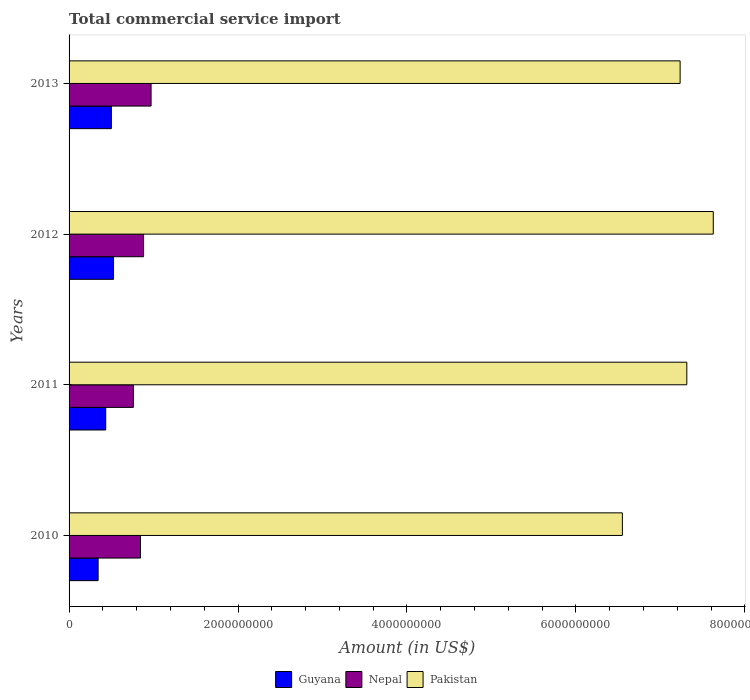How many groups of bars are there?
Offer a very short reply. 4. What is the label of the 4th group of bars from the top?
Your response must be concise. 2010. In how many cases, is the number of bars for a given year not equal to the number of legend labels?
Your answer should be compact. 0. What is the total commercial service import in Nepal in 2011?
Keep it short and to the point. 7.61e+08. Across all years, what is the maximum total commercial service import in Pakistan?
Your answer should be compact. 7.63e+09. Across all years, what is the minimum total commercial service import in Pakistan?
Your response must be concise. 6.55e+09. What is the total total commercial service import in Nepal in the graph?
Offer a terse response. 3.46e+09. What is the difference between the total commercial service import in Guyana in 2012 and that in 2013?
Ensure brevity in your answer.  2.60e+07. What is the difference between the total commercial service import in Nepal in 2010 and the total commercial service import in Guyana in 2011?
Provide a short and direct response. 4.11e+08. What is the average total commercial service import in Nepal per year?
Your answer should be compact. 8.65e+08. In the year 2010, what is the difference between the total commercial service import in Guyana and total commercial service import in Pakistan?
Give a very brief answer. -6.21e+09. What is the ratio of the total commercial service import in Nepal in 2011 to that in 2012?
Offer a terse response. 0.86. Is the total commercial service import in Guyana in 2012 less than that in 2013?
Offer a terse response. No. What is the difference between the highest and the second highest total commercial service import in Guyana?
Make the answer very short. 2.60e+07. What is the difference between the highest and the lowest total commercial service import in Nepal?
Give a very brief answer. 2.09e+08. Is the sum of the total commercial service import in Guyana in 2010 and 2013 greater than the maximum total commercial service import in Nepal across all years?
Ensure brevity in your answer.  No. What does the 3rd bar from the top in 2013 represents?
Provide a succinct answer. Guyana. What does the 1st bar from the bottom in 2010 represents?
Your response must be concise. Guyana. Is it the case that in every year, the sum of the total commercial service import in Guyana and total commercial service import in Nepal is greater than the total commercial service import in Pakistan?
Your answer should be very brief. No. Are all the bars in the graph horizontal?
Ensure brevity in your answer.  Yes. How many years are there in the graph?
Give a very brief answer. 4. How are the legend labels stacked?
Provide a short and direct response. Horizontal. What is the title of the graph?
Provide a succinct answer. Total commercial service import. What is the label or title of the X-axis?
Ensure brevity in your answer.  Amount (in US$). What is the label or title of the Y-axis?
Provide a short and direct response. Years. What is the Amount (in US$) in Guyana in 2010?
Your answer should be compact. 3.44e+08. What is the Amount (in US$) in Nepal in 2010?
Your answer should be very brief. 8.45e+08. What is the Amount (in US$) in Pakistan in 2010?
Your response must be concise. 6.55e+09. What is the Amount (in US$) in Guyana in 2011?
Provide a succinct answer. 4.34e+08. What is the Amount (in US$) of Nepal in 2011?
Provide a succinct answer. 7.61e+08. What is the Amount (in US$) in Pakistan in 2011?
Provide a short and direct response. 7.31e+09. What is the Amount (in US$) of Guyana in 2012?
Offer a terse response. 5.26e+08. What is the Amount (in US$) in Nepal in 2012?
Your answer should be very brief. 8.82e+08. What is the Amount (in US$) of Pakistan in 2012?
Your answer should be compact. 7.63e+09. What is the Amount (in US$) of Guyana in 2013?
Your response must be concise. 5.00e+08. What is the Amount (in US$) of Nepal in 2013?
Offer a very short reply. 9.71e+08. What is the Amount (in US$) in Pakistan in 2013?
Make the answer very short. 7.23e+09. Across all years, what is the maximum Amount (in US$) in Guyana?
Offer a terse response. 5.26e+08. Across all years, what is the maximum Amount (in US$) of Nepal?
Offer a very short reply. 9.71e+08. Across all years, what is the maximum Amount (in US$) in Pakistan?
Keep it short and to the point. 7.63e+09. Across all years, what is the minimum Amount (in US$) of Guyana?
Provide a succinct answer. 3.44e+08. Across all years, what is the minimum Amount (in US$) in Nepal?
Your answer should be very brief. 7.61e+08. Across all years, what is the minimum Amount (in US$) in Pakistan?
Make the answer very short. 6.55e+09. What is the total Amount (in US$) in Guyana in the graph?
Provide a succinct answer. 1.80e+09. What is the total Amount (in US$) of Nepal in the graph?
Your response must be concise. 3.46e+09. What is the total Amount (in US$) of Pakistan in the graph?
Provide a short and direct response. 2.87e+1. What is the difference between the Amount (in US$) in Guyana in 2010 and that in 2011?
Your answer should be compact. -8.99e+07. What is the difference between the Amount (in US$) in Nepal in 2010 and that in 2011?
Your answer should be compact. 8.38e+07. What is the difference between the Amount (in US$) of Pakistan in 2010 and that in 2011?
Offer a very short reply. -7.63e+08. What is the difference between the Amount (in US$) in Guyana in 2010 and that in 2012?
Give a very brief answer. -1.83e+08. What is the difference between the Amount (in US$) of Nepal in 2010 and that in 2012?
Offer a very short reply. -3.66e+07. What is the difference between the Amount (in US$) of Pakistan in 2010 and that in 2012?
Ensure brevity in your answer.  -1.08e+09. What is the difference between the Amount (in US$) in Guyana in 2010 and that in 2013?
Give a very brief answer. -1.57e+08. What is the difference between the Amount (in US$) of Nepal in 2010 and that in 2013?
Make the answer very short. -1.26e+08. What is the difference between the Amount (in US$) in Pakistan in 2010 and that in 2013?
Keep it short and to the point. -6.84e+08. What is the difference between the Amount (in US$) in Guyana in 2011 and that in 2012?
Offer a terse response. -9.26e+07. What is the difference between the Amount (in US$) in Nepal in 2011 and that in 2012?
Provide a succinct answer. -1.20e+08. What is the difference between the Amount (in US$) of Pakistan in 2011 and that in 2012?
Give a very brief answer. -3.13e+08. What is the difference between the Amount (in US$) in Guyana in 2011 and that in 2013?
Offer a terse response. -6.66e+07. What is the difference between the Amount (in US$) in Nepal in 2011 and that in 2013?
Your answer should be compact. -2.09e+08. What is the difference between the Amount (in US$) of Pakistan in 2011 and that in 2013?
Ensure brevity in your answer.  7.90e+07. What is the difference between the Amount (in US$) of Guyana in 2012 and that in 2013?
Make the answer very short. 2.60e+07. What is the difference between the Amount (in US$) in Nepal in 2012 and that in 2013?
Keep it short and to the point. -8.89e+07. What is the difference between the Amount (in US$) of Pakistan in 2012 and that in 2013?
Give a very brief answer. 3.92e+08. What is the difference between the Amount (in US$) in Guyana in 2010 and the Amount (in US$) in Nepal in 2011?
Make the answer very short. -4.18e+08. What is the difference between the Amount (in US$) in Guyana in 2010 and the Amount (in US$) in Pakistan in 2011?
Ensure brevity in your answer.  -6.97e+09. What is the difference between the Amount (in US$) of Nepal in 2010 and the Amount (in US$) of Pakistan in 2011?
Make the answer very short. -6.47e+09. What is the difference between the Amount (in US$) of Guyana in 2010 and the Amount (in US$) of Nepal in 2012?
Your answer should be compact. -5.38e+08. What is the difference between the Amount (in US$) of Guyana in 2010 and the Amount (in US$) of Pakistan in 2012?
Offer a very short reply. -7.28e+09. What is the difference between the Amount (in US$) in Nepal in 2010 and the Amount (in US$) in Pakistan in 2012?
Your answer should be very brief. -6.78e+09. What is the difference between the Amount (in US$) of Guyana in 2010 and the Amount (in US$) of Nepal in 2013?
Provide a succinct answer. -6.27e+08. What is the difference between the Amount (in US$) of Guyana in 2010 and the Amount (in US$) of Pakistan in 2013?
Provide a succinct answer. -6.89e+09. What is the difference between the Amount (in US$) of Nepal in 2010 and the Amount (in US$) of Pakistan in 2013?
Offer a terse response. -6.39e+09. What is the difference between the Amount (in US$) of Guyana in 2011 and the Amount (in US$) of Nepal in 2012?
Your response must be concise. -4.48e+08. What is the difference between the Amount (in US$) of Guyana in 2011 and the Amount (in US$) of Pakistan in 2012?
Provide a short and direct response. -7.19e+09. What is the difference between the Amount (in US$) of Nepal in 2011 and the Amount (in US$) of Pakistan in 2012?
Make the answer very short. -6.86e+09. What is the difference between the Amount (in US$) of Guyana in 2011 and the Amount (in US$) of Nepal in 2013?
Ensure brevity in your answer.  -5.37e+08. What is the difference between the Amount (in US$) in Guyana in 2011 and the Amount (in US$) in Pakistan in 2013?
Provide a succinct answer. -6.80e+09. What is the difference between the Amount (in US$) in Nepal in 2011 and the Amount (in US$) in Pakistan in 2013?
Your answer should be very brief. -6.47e+09. What is the difference between the Amount (in US$) in Guyana in 2012 and the Amount (in US$) in Nepal in 2013?
Offer a terse response. -4.44e+08. What is the difference between the Amount (in US$) in Guyana in 2012 and the Amount (in US$) in Pakistan in 2013?
Ensure brevity in your answer.  -6.71e+09. What is the difference between the Amount (in US$) in Nepal in 2012 and the Amount (in US$) in Pakistan in 2013?
Offer a very short reply. -6.35e+09. What is the average Amount (in US$) in Guyana per year?
Provide a short and direct response. 4.51e+08. What is the average Amount (in US$) in Nepal per year?
Make the answer very short. 8.65e+08. What is the average Amount (in US$) in Pakistan per year?
Make the answer very short. 7.18e+09. In the year 2010, what is the difference between the Amount (in US$) of Guyana and Amount (in US$) of Nepal?
Provide a short and direct response. -5.01e+08. In the year 2010, what is the difference between the Amount (in US$) of Guyana and Amount (in US$) of Pakistan?
Offer a very short reply. -6.21e+09. In the year 2010, what is the difference between the Amount (in US$) in Nepal and Amount (in US$) in Pakistan?
Give a very brief answer. -5.70e+09. In the year 2011, what is the difference between the Amount (in US$) in Guyana and Amount (in US$) in Nepal?
Your response must be concise. -3.28e+08. In the year 2011, what is the difference between the Amount (in US$) of Guyana and Amount (in US$) of Pakistan?
Your response must be concise. -6.88e+09. In the year 2011, what is the difference between the Amount (in US$) in Nepal and Amount (in US$) in Pakistan?
Your response must be concise. -6.55e+09. In the year 2012, what is the difference between the Amount (in US$) in Guyana and Amount (in US$) in Nepal?
Offer a very short reply. -3.55e+08. In the year 2012, what is the difference between the Amount (in US$) in Guyana and Amount (in US$) in Pakistan?
Your answer should be compact. -7.10e+09. In the year 2012, what is the difference between the Amount (in US$) in Nepal and Amount (in US$) in Pakistan?
Provide a succinct answer. -6.74e+09. In the year 2013, what is the difference between the Amount (in US$) in Guyana and Amount (in US$) in Nepal?
Offer a very short reply. -4.70e+08. In the year 2013, what is the difference between the Amount (in US$) of Guyana and Amount (in US$) of Pakistan?
Your answer should be compact. -6.73e+09. In the year 2013, what is the difference between the Amount (in US$) in Nepal and Amount (in US$) in Pakistan?
Provide a succinct answer. -6.26e+09. What is the ratio of the Amount (in US$) in Guyana in 2010 to that in 2011?
Give a very brief answer. 0.79. What is the ratio of the Amount (in US$) in Nepal in 2010 to that in 2011?
Offer a very short reply. 1.11. What is the ratio of the Amount (in US$) in Pakistan in 2010 to that in 2011?
Give a very brief answer. 0.9. What is the ratio of the Amount (in US$) of Guyana in 2010 to that in 2012?
Provide a short and direct response. 0.65. What is the ratio of the Amount (in US$) of Nepal in 2010 to that in 2012?
Keep it short and to the point. 0.96. What is the ratio of the Amount (in US$) in Pakistan in 2010 to that in 2012?
Provide a succinct answer. 0.86. What is the ratio of the Amount (in US$) in Guyana in 2010 to that in 2013?
Your answer should be very brief. 0.69. What is the ratio of the Amount (in US$) in Nepal in 2010 to that in 2013?
Your answer should be compact. 0.87. What is the ratio of the Amount (in US$) of Pakistan in 2010 to that in 2013?
Give a very brief answer. 0.91. What is the ratio of the Amount (in US$) of Guyana in 2011 to that in 2012?
Your answer should be very brief. 0.82. What is the ratio of the Amount (in US$) in Nepal in 2011 to that in 2012?
Ensure brevity in your answer.  0.86. What is the ratio of the Amount (in US$) of Pakistan in 2011 to that in 2012?
Provide a short and direct response. 0.96. What is the ratio of the Amount (in US$) in Guyana in 2011 to that in 2013?
Your response must be concise. 0.87. What is the ratio of the Amount (in US$) in Nepal in 2011 to that in 2013?
Offer a terse response. 0.78. What is the ratio of the Amount (in US$) in Pakistan in 2011 to that in 2013?
Your answer should be compact. 1.01. What is the ratio of the Amount (in US$) in Guyana in 2012 to that in 2013?
Provide a succinct answer. 1.05. What is the ratio of the Amount (in US$) of Nepal in 2012 to that in 2013?
Keep it short and to the point. 0.91. What is the ratio of the Amount (in US$) in Pakistan in 2012 to that in 2013?
Offer a very short reply. 1.05. What is the difference between the highest and the second highest Amount (in US$) of Guyana?
Offer a terse response. 2.60e+07. What is the difference between the highest and the second highest Amount (in US$) in Nepal?
Keep it short and to the point. 8.89e+07. What is the difference between the highest and the second highest Amount (in US$) of Pakistan?
Offer a terse response. 3.13e+08. What is the difference between the highest and the lowest Amount (in US$) of Guyana?
Provide a short and direct response. 1.83e+08. What is the difference between the highest and the lowest Amount (in US$) of Nepal?
Your answer should be compact. 2.09e+08. What is the difference between the highest and the lowest Amount (in US$) in Pakistan?
Your response must be concise. 1.08e+09. 